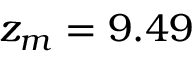Convert formula to latex. <formula><loc_0><loc_0><loc_500><loc_500>z _ { m } = 9 . 4 9</formula> 